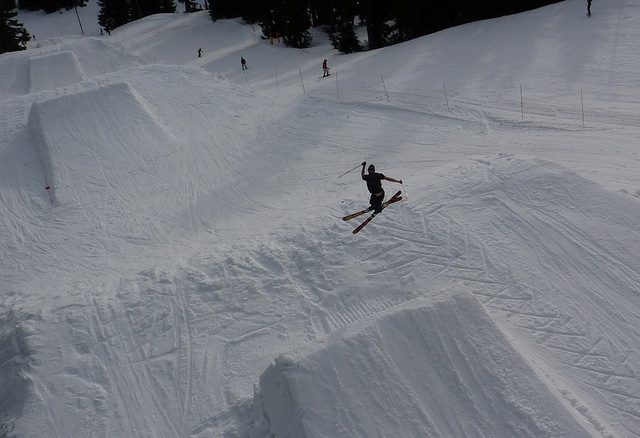Describe the objects in this image and their specific colors. I can see people in black, darkgray, and gray tones, skis in black, gray, maroon, and darkgreen tones, people in black, gray, and darkgray tones, people in black and gray tones, and people in black, gray, and darkblue tones in this image. 